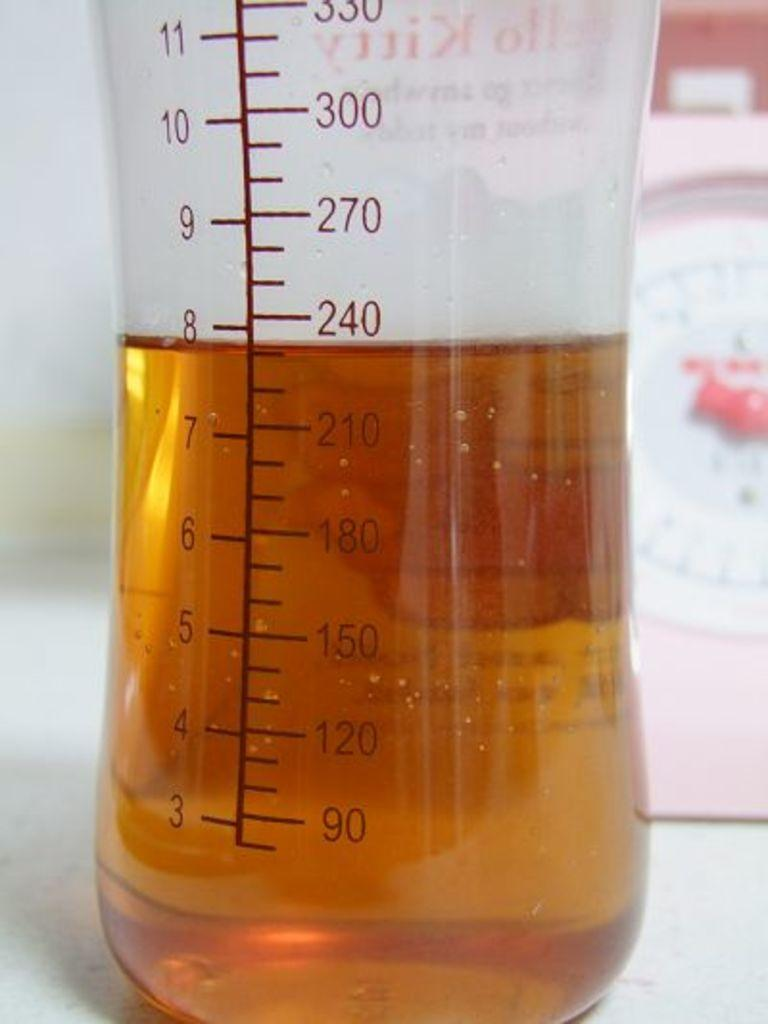<image>
Write a terse but informative summary of the picture. A baby bottle with eight ounces of juice in it. 